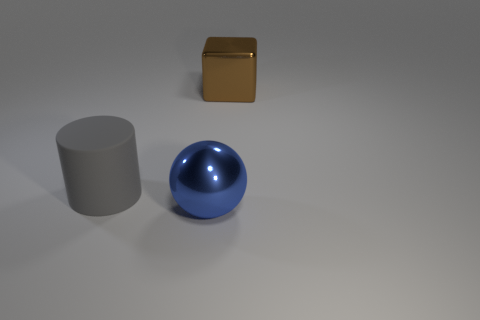Is the shape of the big object in front of the gray object the same as the big metal object that is behind the rubber cylinder?
Your response must be concise. No. What is the blue object made of?
Provide a succinct answer. Metal. What number of balls are the same size as the cylinder?
Offer a terse response. 1. What number of things are either large metallic things that are behind the big gray rubber thing or metallic things that are behind the large cylinder?
Ensure brevity in your answer.  1. Is the big brown object that is behind the gray cylinder made of the same material as the big object that is to the left of the blue metallic thing?
Give a very brief answer. No. There is a big thing that is on the left side of the shiny object that is in front of the brown shiny thing; what shape is it?
Offer a very short reply. Cylinder. Is there anything else that is the same color as the metallic block?
Keep it short and to the point. No. Is there a gray cylinder behind the metal object that is to the right of the metallic object that is in front of the big cube?
Provide a succinct answer. No. Does the big object that is behind the large cylinder have the same color as the metallic thing that is on the left side of the big brown metallic thing?
Your answer should be very brief. No. There is a blue object that is the same size as the brown cube; what is its material?
Your answer should be compact. Metal. 